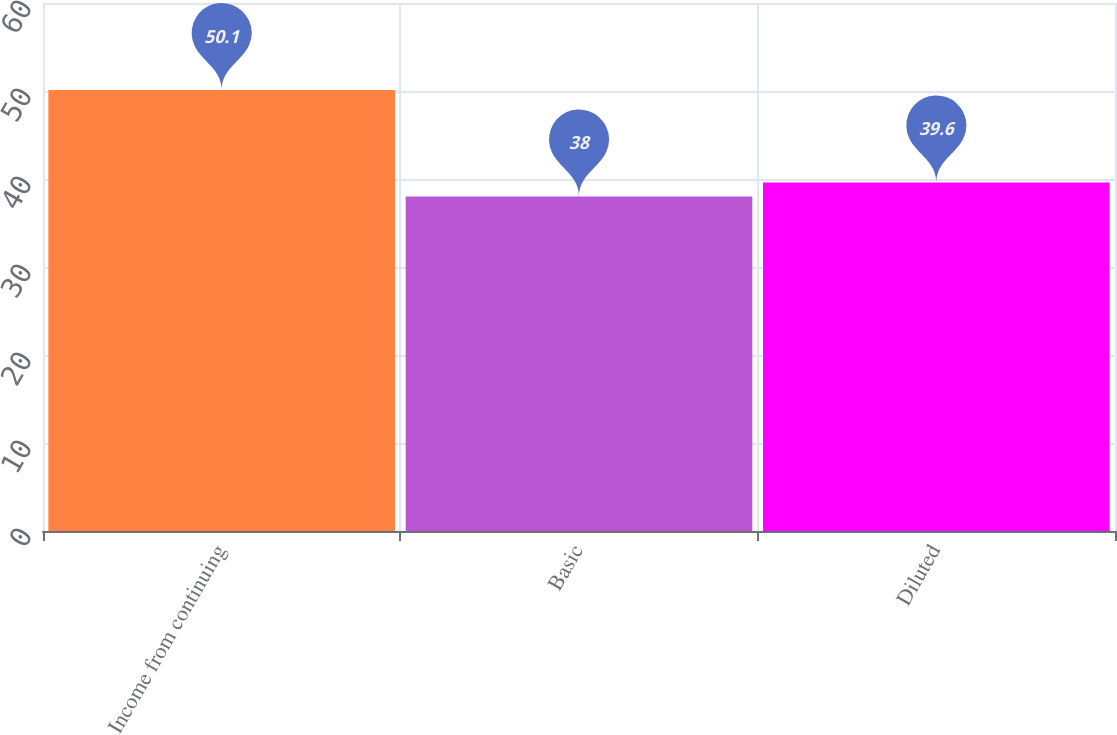Convert chart to OTSL. <chart><loc_0><loc_0><loc_500><loc_500><bar_chart><fcel>Income from continuing<fcel>Basic<fcel>Diluted<nl><fcel>50.1<fcel>38<fcel>39.6<nl></chart> 